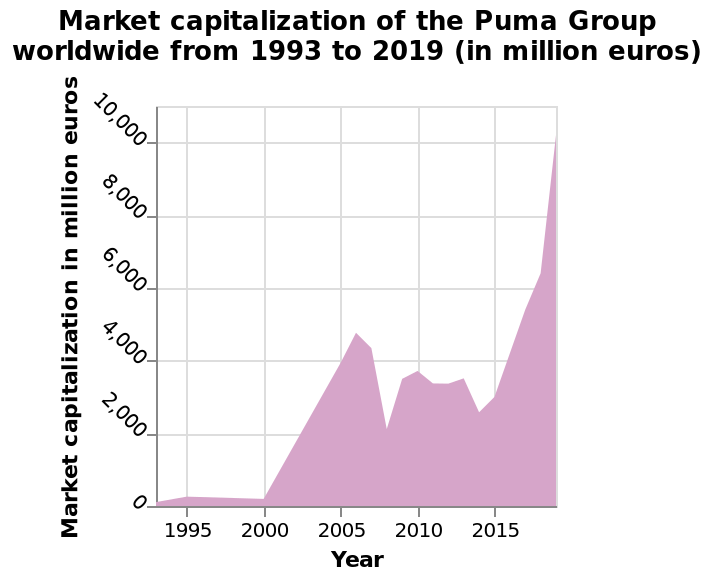<image>
What has been the trend of market capitalisation?  The market capitalisation has been erratic, trending upwards with a sharp increase in 2014. When did the market capitalisation experience a significant rise?  The market capitalisation experienced a sharp increase in 2014. please enumerates aspects of the construction of the chart Market capitalization of the Puma Group worldwide from 1993 to 2019 (in million euros) is a area chart. The y-axis measures Market capitalization in million euros while the x-axis shows Year. What is the time range covered by the data in the area chart? The data in the area chart covers the time range from 1993 to 2019. How is the market capitalization of the Puma Group worldwide represented on the chart? The market capitalization of the Puma Group worldwide is represented by an area chart. How has the market capitalisation been behaving?  The market capitalisation has been erratic, with an overall upward trend. Has the market capitalisation been stable or fluctuating?  The market capitalisation has been fluctuating, showing an erratic pattern. 